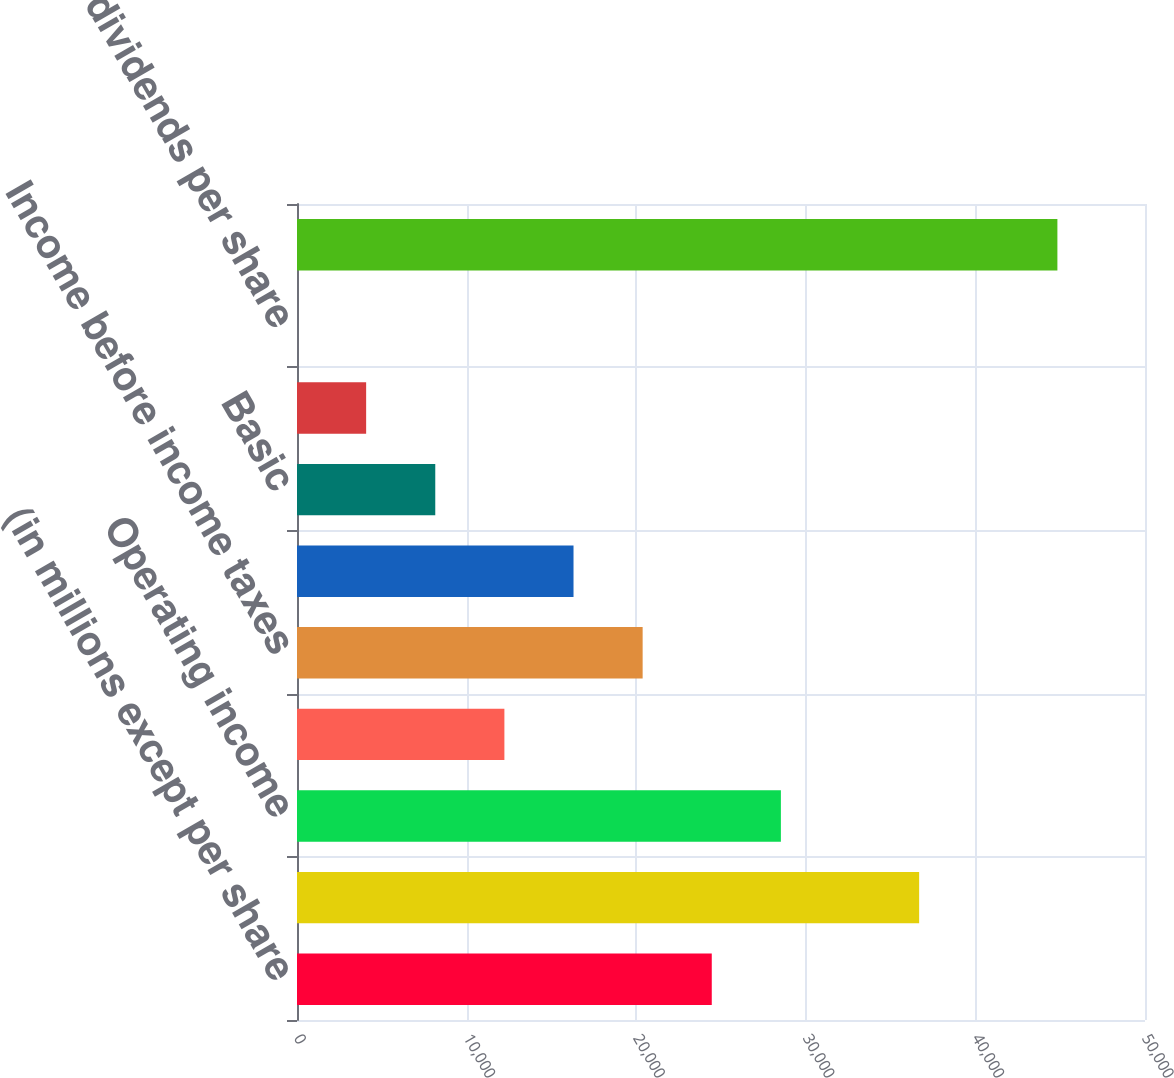Convert chart to OTSL. <chart><loc_0><loc_0><loc_500><loc_500><bar_chart><fcel>(in millions except per share<fcel>Total revenues<fcel>Operating income<fcel>Non-operating income (expense)<fcel>Income before income taxes<fcel>Net income attributable to CME<fcel>Basic<fcel>Diluted<fcel>Cash dividends per share<fcel>Total assets<nl><fcel>24455.7<fcel>36683<fcel>28531.4<fcel>12228.4<fcel>20379.9<fcel>16304.2<fcel>8152.64<fcel>4076.88<fcel>1.12<fcel>44834.5<nl></chart> 